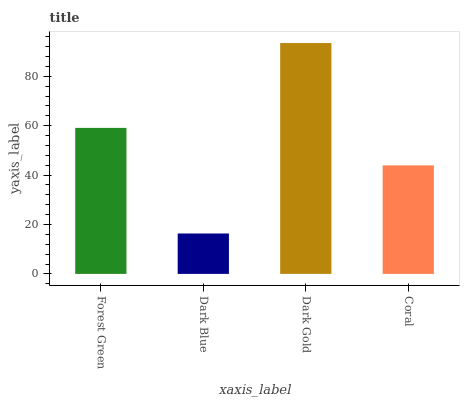Is Dark Blue the minimum?
Answer yes or no. Yes. Is Dark Gold the maximum?
Answer yes or no. Yes. Is Dark Gold the minimum?
Answer yes or no. No. Is Dark Blue the maximum?
Answer yes or no. No. Is Dark Gold greater than Dark Blue?
Answer yes or no. Yes. Is Dark Blue less than Dark Gold?
Answer yes or no. Yes. Is Dark Blue greater than Dark Gold?
Answer yes or no. No. Is Dark Gold less than Dark Blue?
Answer yes or no. No. Is Forest Green the high median?
Answer yes or no. Yes. Is Coral the low median?
Answer yes or no. Yes. Is Coral the high median?
Answer yes or no. No. Is Dark Gold the low median?
Answer yes or no. No. 